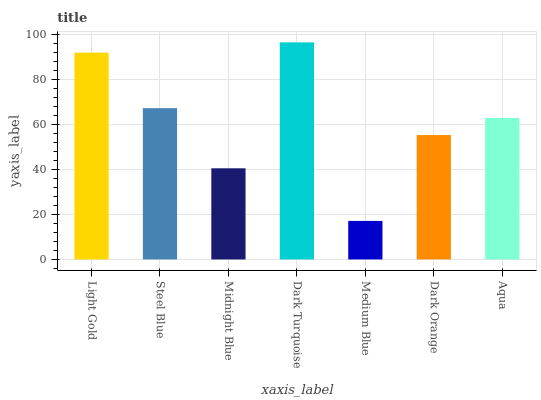Is Medium Blue the minimum?
Answer yes or no. Yes. Is Dark Turquoise the maximum?
Answer yes or no. Yes. Is Steel Blue the minimum?
Answer yes or no. No. Is Steel Blue the maximum?
Answer yes or no. No. Is Light Gold greater than Steel Blue?
Answer yes or no. Yes. Is Steel Blue less than Light Gold?
Answer yes or no. Yes. Is Steel Blue greater than Light Gold?
Answer yes or no. No. Is Light Gold less than Steel Blue?
Answer yes or no. No. Is Aqua the high median?
Answer yes or no. Yes. Is Aqua the low median?
Answer yes or no. Yes. Is Medium Blue the high median?
Answer yes or no. No. Is Medium Blue the low median?
Answer yes or no. No. 